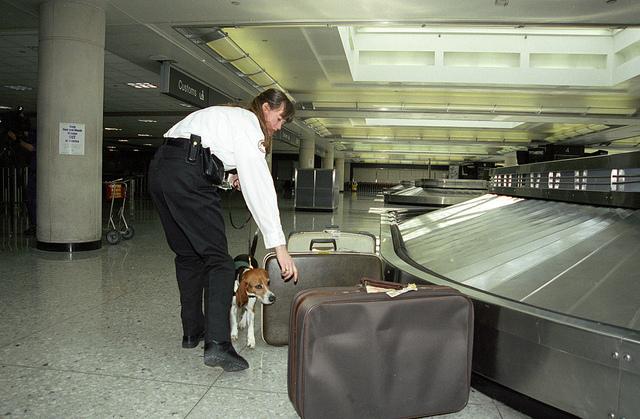Is this an airport?
Give a very brief answer. Yes. Is the dog on a leash?
Short answer required. Yes. Why is the dog at the airport?
Be succinct. Find drugs. 